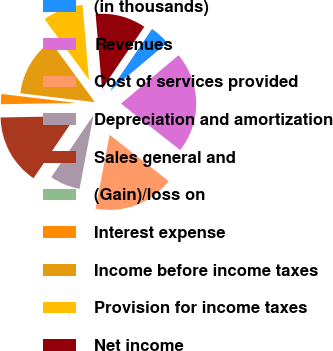<chart> <loc_0><loc_0><loc_500><loc_500><pie_chart><fcel>(in thousands)<fcel>Revenues<fcel>Cost of services provided<fcel>Depreciation and amortization<fcel>Sales general and<fcel>(Gain)/loss on<fcel>Interest expense<fcel>Income before income taxes<fcel>Provision for income taxes<fcel>Net income<nl><fcel>4.35%<fcel>21.73%<fcel>17.39%<fcel>6.52%<fcel>15.21%<fcel>0.01%<fcel>2.18%<fcel>13.04%<fcel>8.7%<fcel>10.87%<nl></chart> 